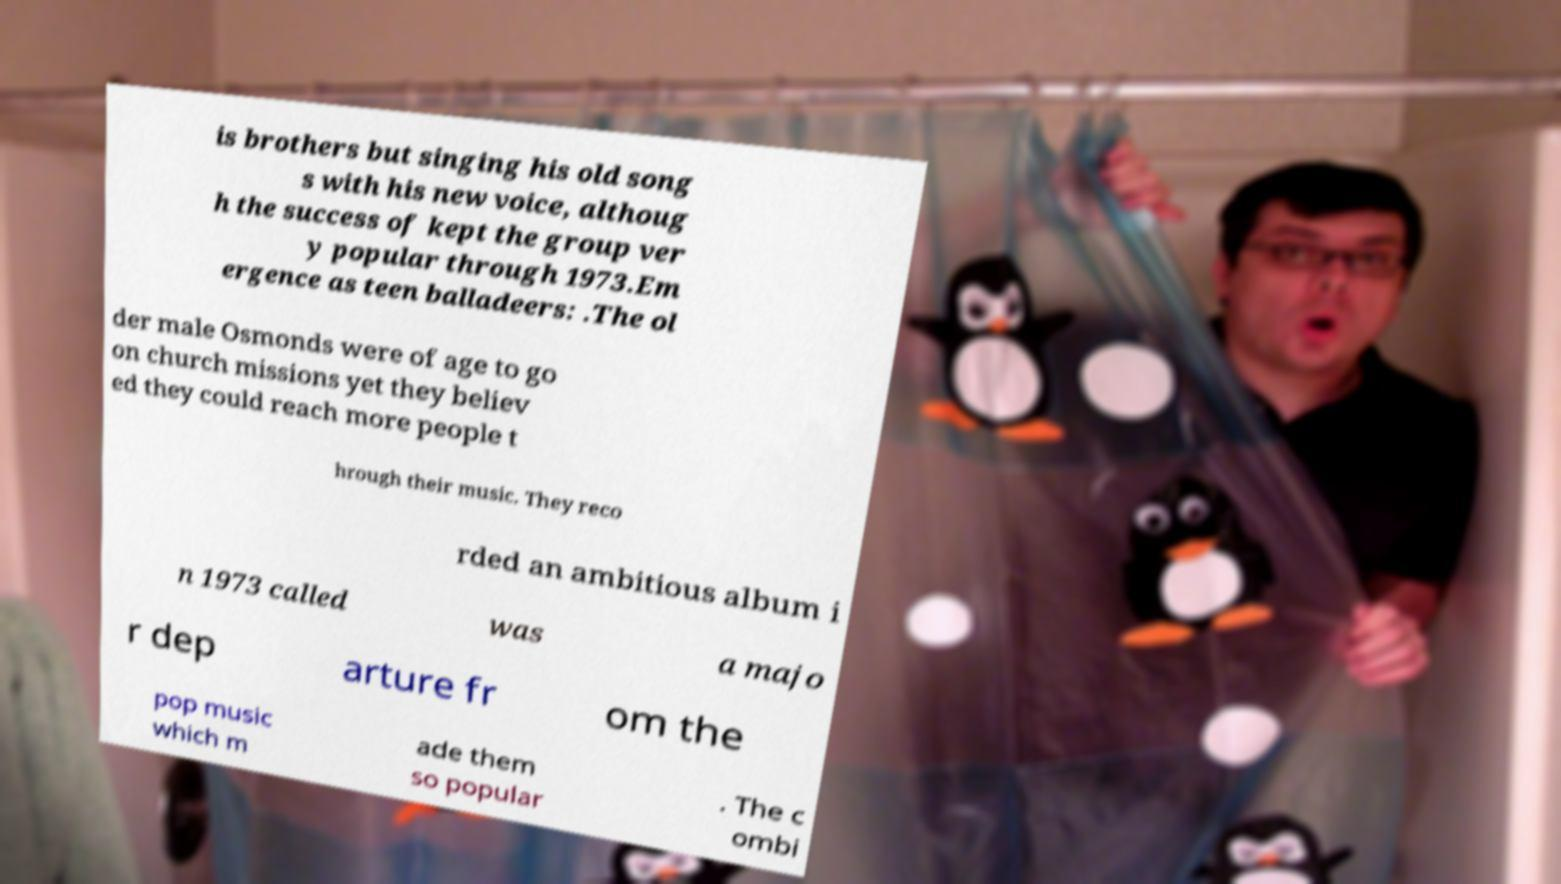I need the written content from this picture converted into text. Can you do that? is brothers but singing his old song s with his new voice, althoug h the success of kept the group ver y popular through 1973.Em ergence as teen balladeers: .The ol der male Osmonds were of age to go on church missions yet they believ ed they could reach more people t hrough their music. They reco rded an ambitious album i n 1973 called was a majo r dep arture fr om the pop music which m ade them so popular . The c ombi 